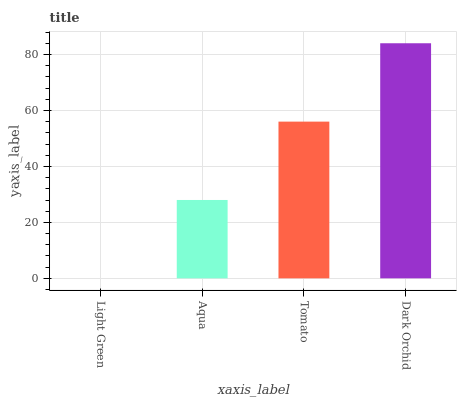Is Light Green the minimum?
Answer yes or no. Yes. Is Dark Orchid the maximum?
Answer yes or no. Yes. Is Aqua the minimum?
Answer yes or no. No. Is Aqua the maximum?
Answer yes or no. No. Is Aqua greater than Light Green?
Answer yes or no. Yes. Is Light Green less than Aqua?
Answer yes or no. Yes. Is Light Green greater than Aqua?
Answer yes or no. No. Is Aqua less than Light Green?
Answer yes or no. No. Is Tomato the high median?
Answer yes or no. Yes. Is Aqua the low median?
Answer yes or no. Yes. Is Aqua the high median?
Answer yes or no. No. Is Light Green the low median?
Answer yes or no. No. 